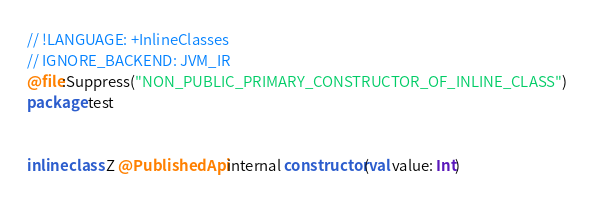<code> <loc_0><loc_0><loc_500><loc_500><_Kotlin_>// !LANGUAGE: +InlineClasses
// IGNORE_BACKEND: JVM_IR
@file:Suppress("NON_PUBLIC_PRIMARY_CONSTRUCTOR_OF_INLINE_CLASS")
package test


inline class Z @PublishedApi internal constructor(val value: Int)</code> 